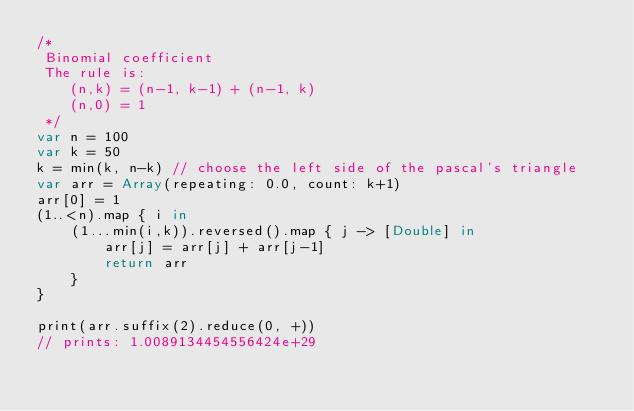Convert code to text. <code><loc_0><loc_0><loc_500><loc_500><_Swift_>/*
 Binomial coefficient
 The rule is:
    (n,k) = (n-1, k-1) + (n-1, k)
    (n,0) = 1
 */
var n = 100
var k = 50
k = min(k, n-k) // choose the left side of the pascal's triangle
var arr = Array(repeating: 0.0, count: k+1)
arr[0] = 1
(1..<n).map { i in
    (1...min(i,k)).reversed().map { j -> [Double] in
        arr[j] = arr[j] + arr[j-1]
        return arr
    }
}

print(arr.suffix(2).reduce(0, +))
// prints: 1.0089134454556424e+29
</code> 